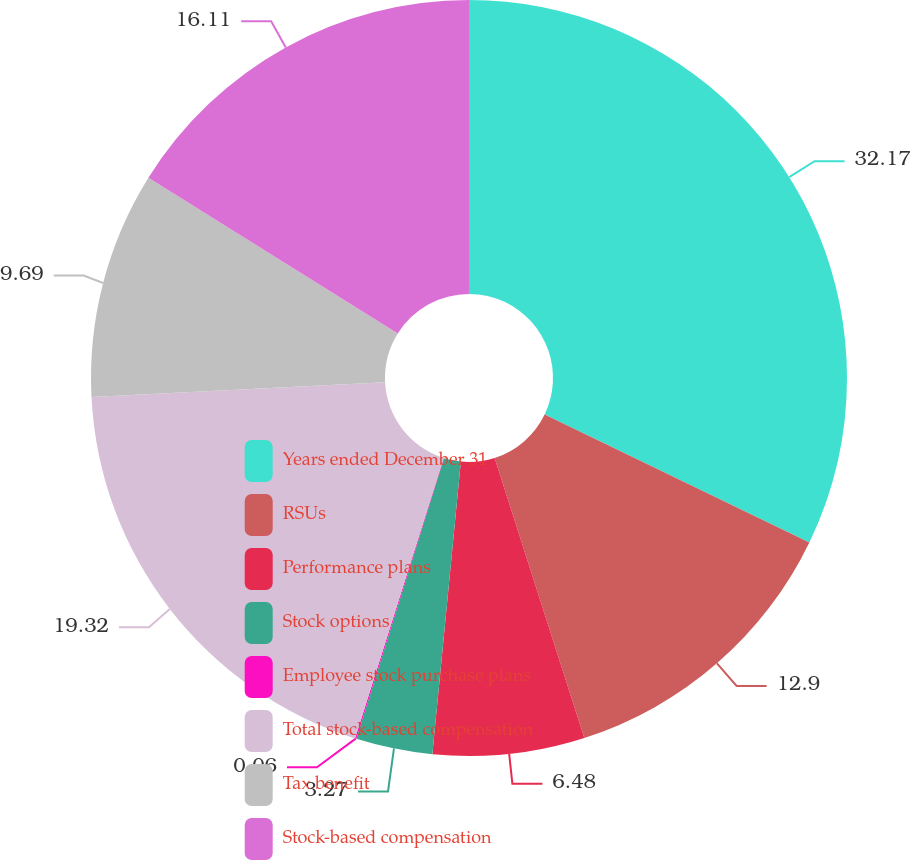<chart> <loc_0><loc_0><loc_500><loc_500><pie_chart><fcel>Years ended December 31<fcel>RSUs<fcel>Performance plans<fcel>Stock options<fcel>Employee stock purchase plans<fcel>Total stock-based compensation<fcel>Tax benefit<fcel>Stock-based compensation<nl><fcel>32.16%<fcel>12.9%<fcel>6.48%<fcel>3.27%<fcel>0.06%<fcel>19.32%<fcel>9.69%<fcel>16.11%<nl></chart> 